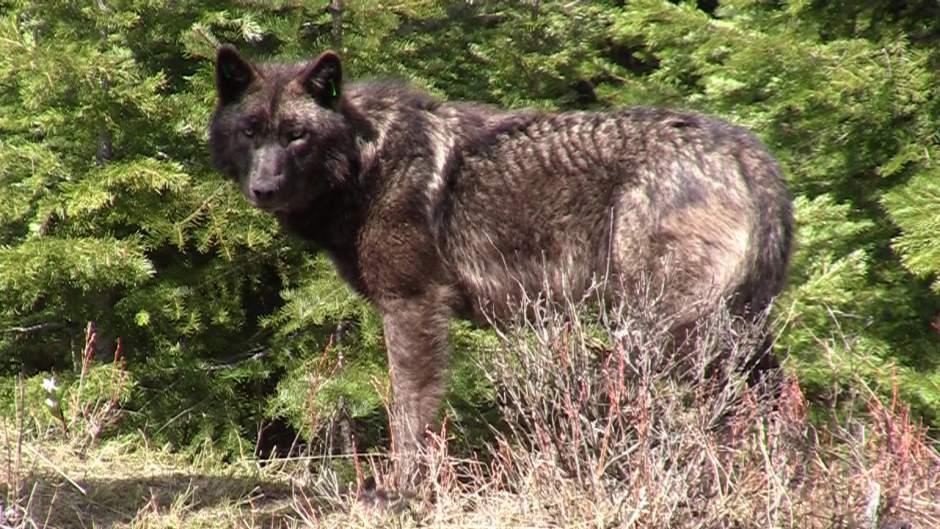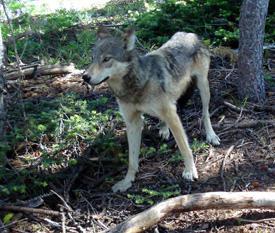The first image is the image on the left, the second image is the image on the right. Evaluate the accuracy of this statement regarding the images: "There is one dog outside in the image on the right.". Is it true? Answer yes or no. Yes. 